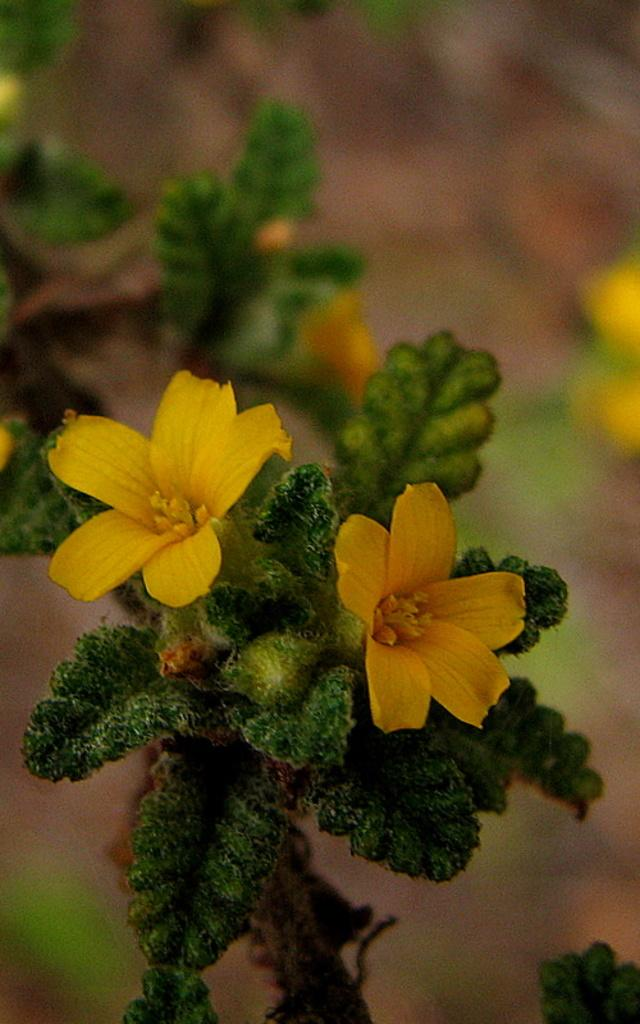What is the main subject of the image? There is a plant in the image. What color are the flowers on the plant? The plant has yellow flowers. Can you describe the background of the image? The background of the image is blurred. How many eggs does the plant's brother have in the image? There is no mention of eggs or a brother in the image, so this question cannot be answered. 